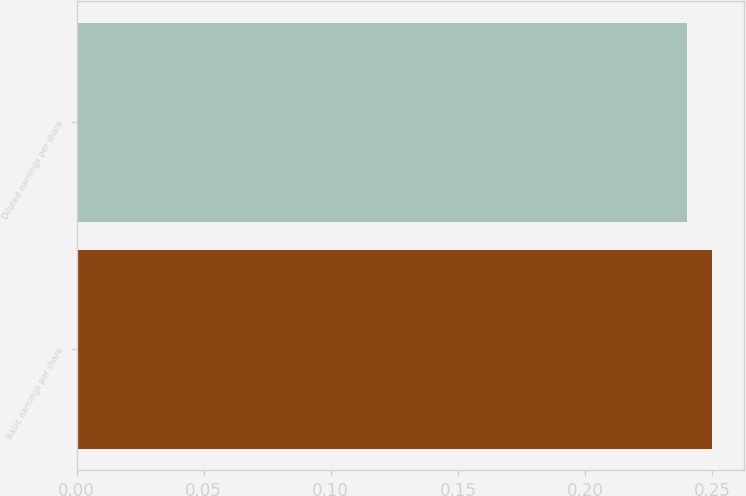Convert chart to OTSL. <chart><loc_0><loc_0><loc_500><loc_500><bar_chart><fcel>Basic earnings per share<fcel>Diluted earnings per share<nl><fcel>0.25<fcel>0.24<nl></chart> 